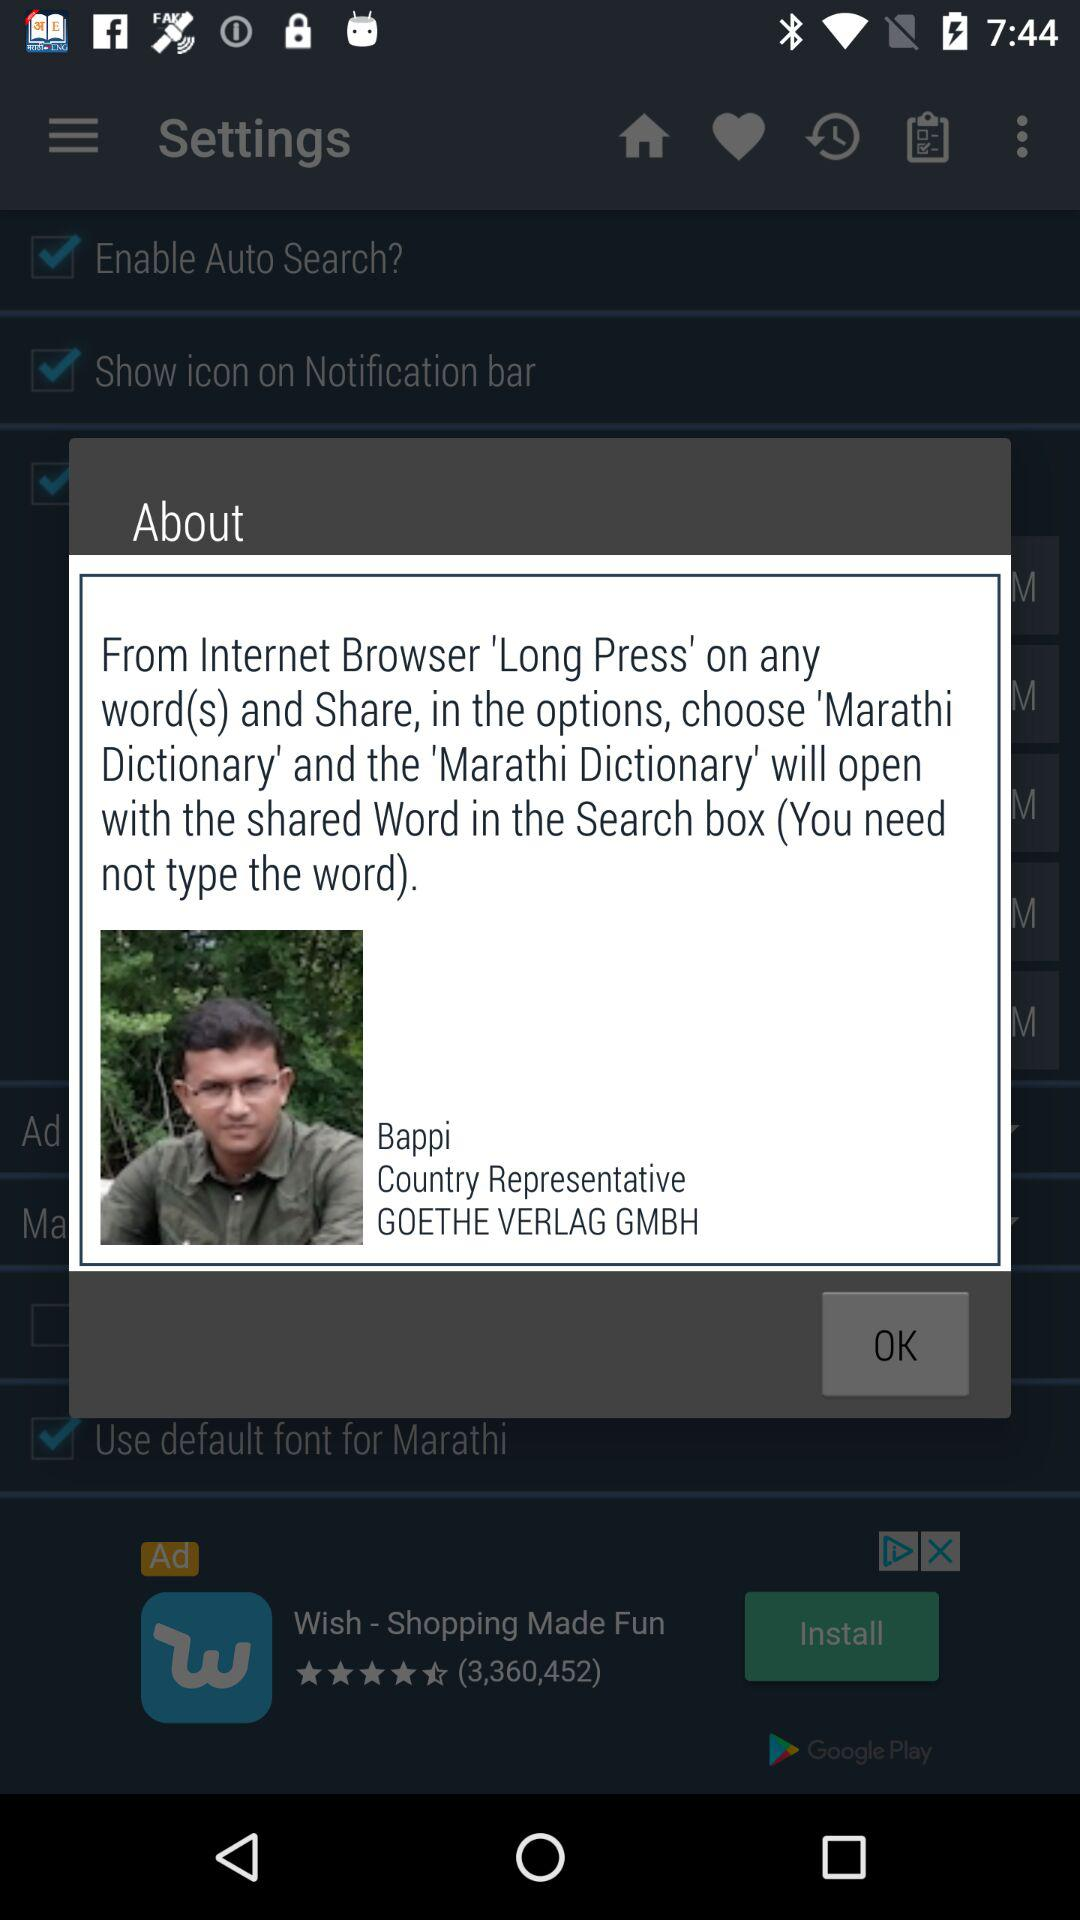What is the name? The name is Bappi. 